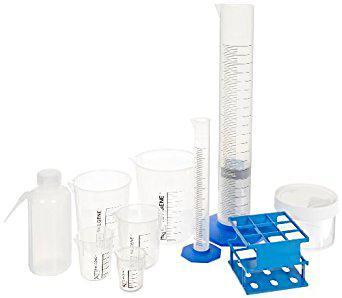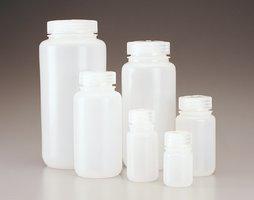The first image is the image on the left, the second image is the image on the right. Considering the images on both sides, is "There are empty beakers." valid? Answer yes or no. Yes. The first image is the image on the left, the second image is the image on the right. Evaluate the accuracy of this statement regarding the images: "The left image shows blue liquid in two containers, and the right image includes multiple capped bottles containing liquid.". Is it true? Answer yes or no. No. 